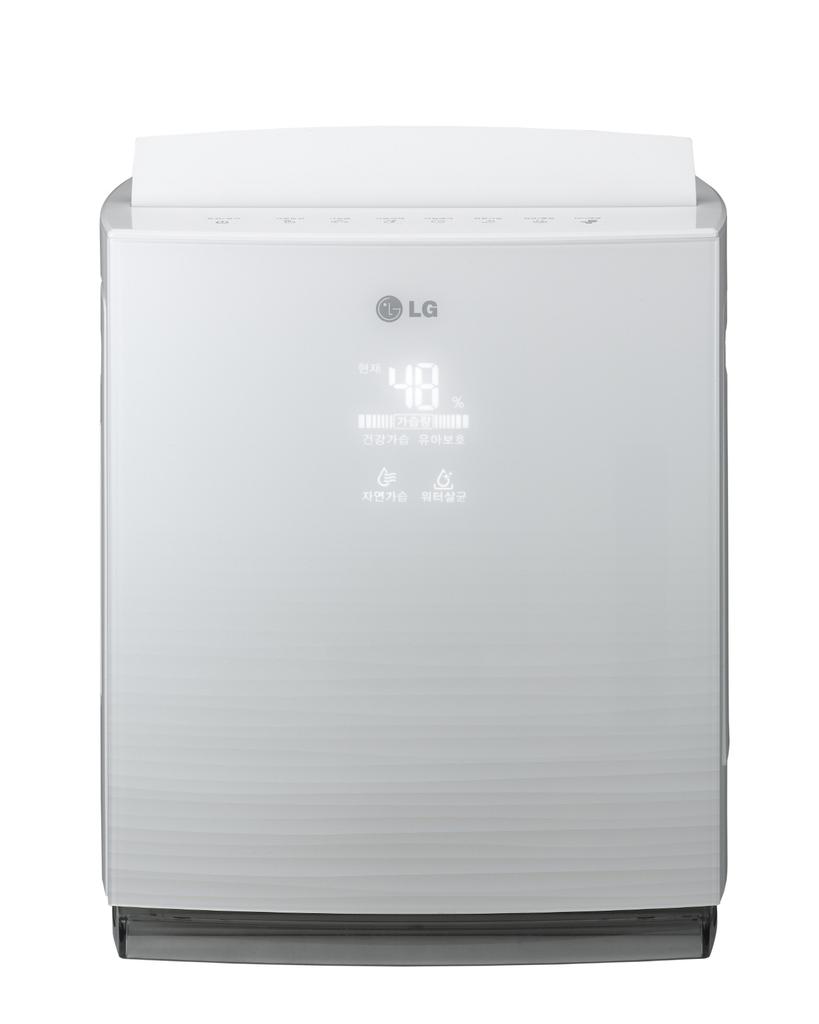What brand is showing?
Your answer should be compact. Lg. What numbers are on the front?
Make the answer very short. 48. 